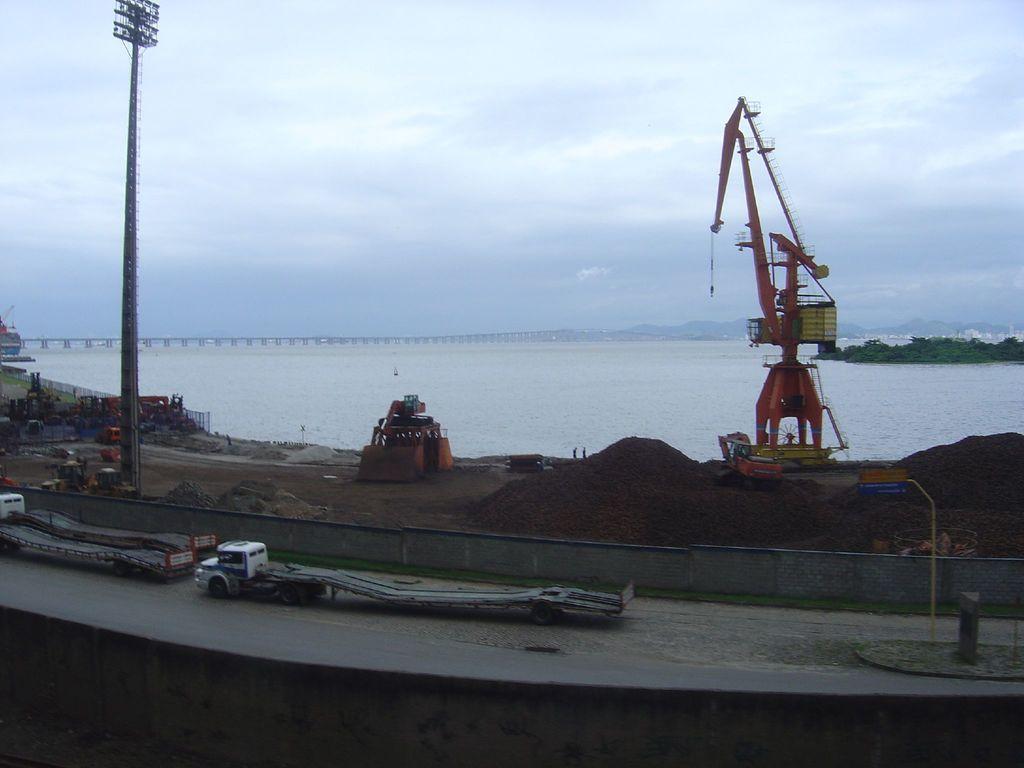Describe this image in one or two sentences. At the bottom of the image we can see vehicles, wall, crane, board and some objects. There is a sea in the middle of the image. In the background, we can see a bridge. At the top of the image, we can see the sky is covered with clouds. We can see greenery on the right side of the image. 